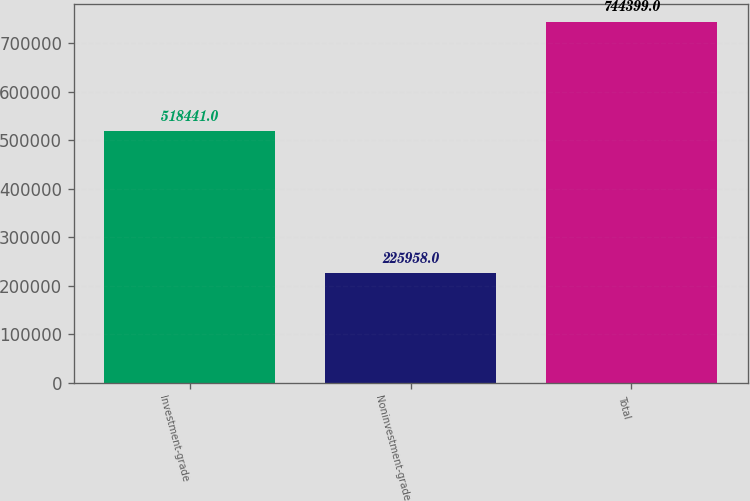Convert chart to OTSL. <chart><loc_0><loc_0><loc_500><loc_500><bar_chart><fcel>Investment-grade<fcel>Noninvestment-grade<fcel>Total<nl><fcel>518441<fcel>225958<fcel>744399<nl></chart> 